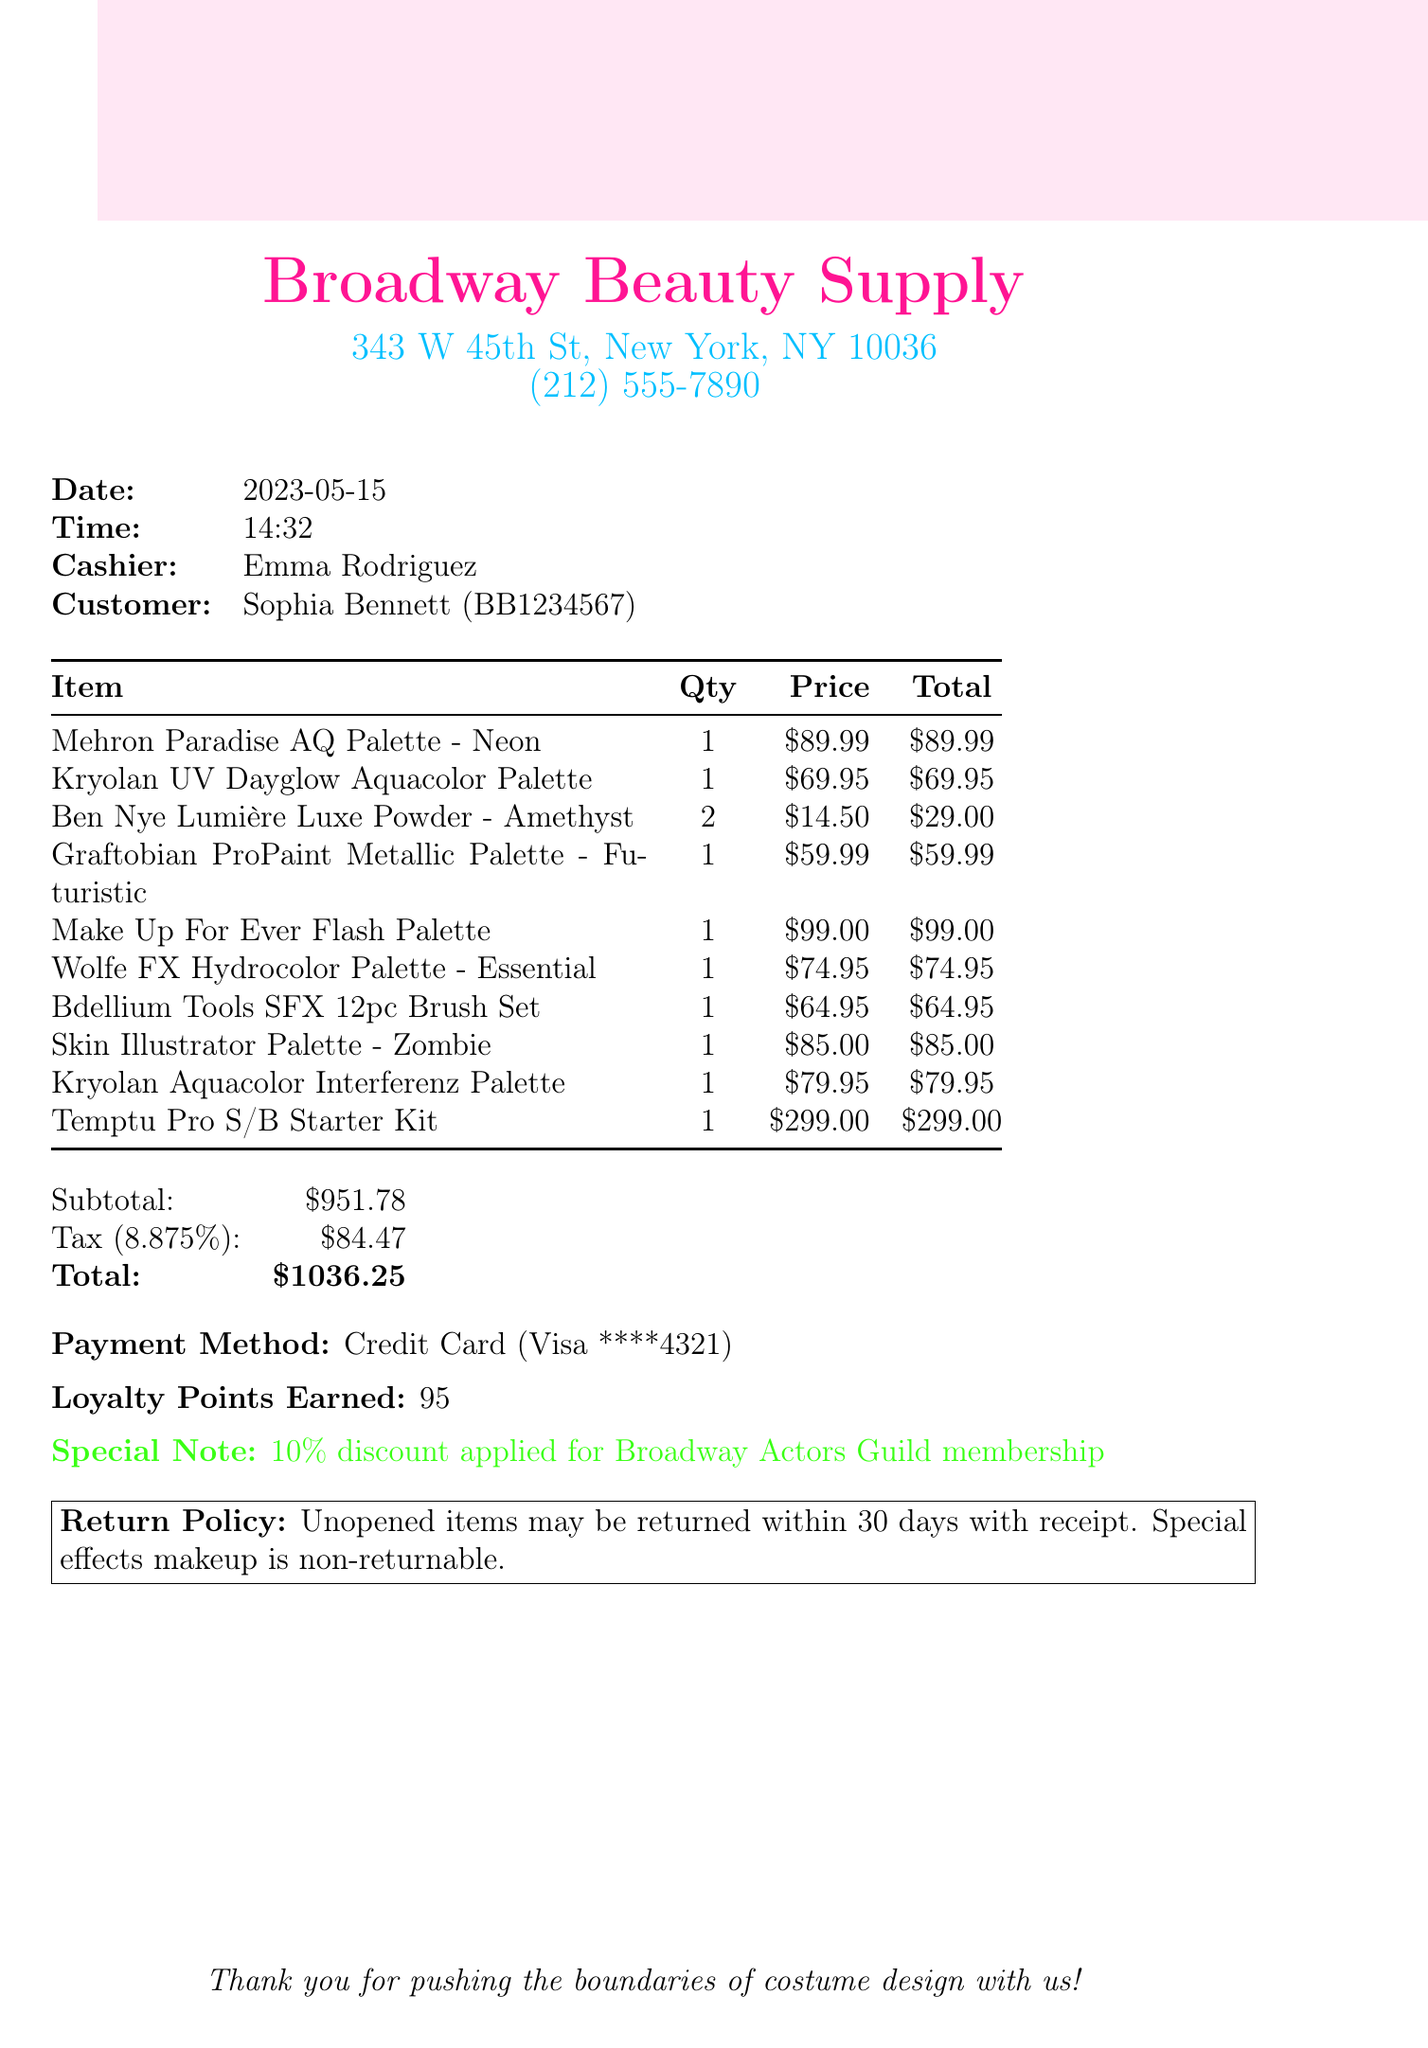What is the store name? The store name is prominently displayed at the top of the document.
Answer: Broadway Beauty Supply What items did Sophia Bennett purchase? The items purchased are listed in a table format, detailing each product.
Answer: Mehron Paradise AQ Palette - Neon, Kryolan UV Dayglow Aquacolor Palette, Ben Nye Lumière Luxe Powder - Amethyst, Graftobian ProPaint Metallic Palette - Futuristic, Make Up For Ever Flash Palette, Wolfe FX Hydrocolor Palette - Essential, Bdellium Tools SFX 12pc Brush Set, Skin Illustrator Palette - Zombie, Kryolan Aquacolor Interferenz Palette, Temptu Pro S/B Starter Kit How many loyalty points did the customer earn? Loyalty points earned are mentioned near the payment details section of the receipt.
Answer: 95 What is the tax rate applied to the purchase? The tax rate is stated clearly in the tax calculation section.
Answer: 8.875% What item has the highest price? The prices of all items are provided, allowing for comparison to identify the most expensive item.
Answer: Temptu Pro S/B Starter Kit What special note is included on the receipt? The special note indicates any discounts applied and is formatted distinctly in neon green text.
Answer: 10% discount applied for Broadway Actors Guild membership What is the total amount of the purchase? The total amount is clearly labeled at the end of the subtotal and tax calculations.
Answer: $1036.25 What is the return policy mentioned in the document? The return policy is outlined in a boxed section at the bottom of the receipt.
Answer: Unopened items may be returned within 30 days with receipt. Special effects makeup is non-returnable Who was the cashier for this transaction? The cashier's name is listed alongside the transaction details.
Answer: Emma Rodriguez 